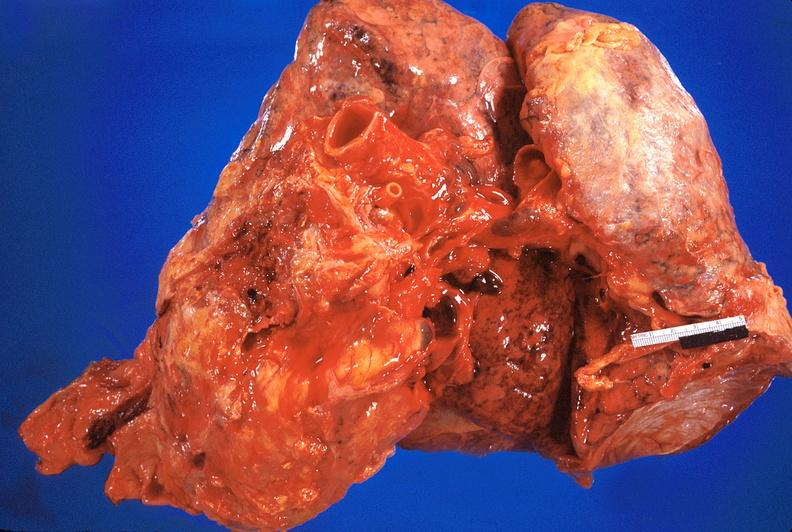what is present?
Answer the question using a single word or phrase. Cardiovascular 